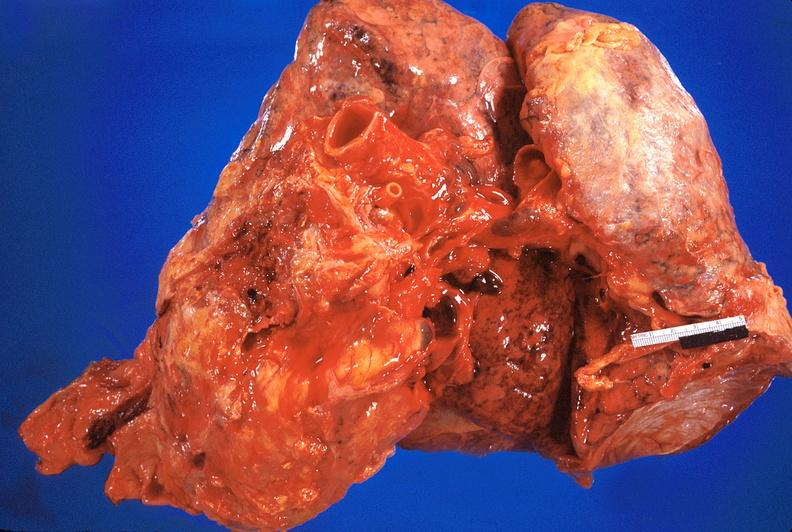what is present?
Answer the question using a single word or phrase. Cardiovascular 